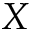Convert formula to latex. <formula><loc_0><loc_0><loc_500><loc_500>X</formula> 